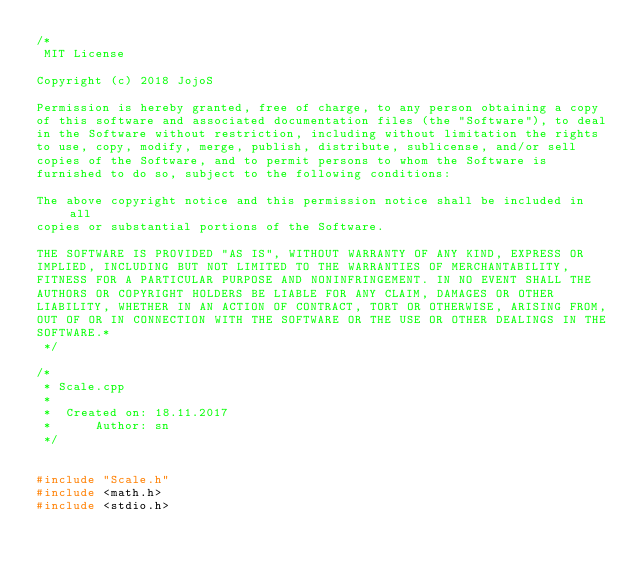Convert code to text. <code><loc_0><loc_0><loc_500><loc_500><_C++_>/*
 MIT License

Copyright (c) 2018 JojoS

Permission is hereby granted, free of charge, to any person obtaining a copy
of this software and associated documentation files (the "Software"), to deal
in the Software without restriction, including without limitation the rights
to use, copy, modify, merge, publish, distribute, sublicense, and/or sell
copies of the Software, and to permit persons to whom the Software is
furnished to do so, subject to the following conditions:

The above copyright notice and this permission notice shall be included in all
copies or substantial portions of the Software.

THE SOFTWARE IS PROVIDED "AS IS", WITHOUT WARRANTY OF ANY KIND, EXPRESS OR
IMPLIED, INCLUDING BUT NOT LIMITED TO THE WARRANTIES OF MERCHANTABILITY,
FITNESS FOR A PARTICULAR PURPOSE AND NONINFRINGEMENT. IN NO EVENT SHALL THE
AUTHORS OR COPYRIGHT HOLDERS BE LIABLE FOR ANY CLAIM, DAMAGES OR OTHER
LIABILITY, WHETHER IN AN ACTION OF CONTRACT, TORT OR OTHERWISE, ARISING FROM,
OUT OF OR IN CONNECTION WITH THE SOFTWARE OR THE USE OR OTHER DEALINGS IN THE
SOFTWARE.*
 */

/*
 * Scale.cpp
 *
 *  Created on: 18.11.2017
 *      Author: sn
 */


#include "Scale.h"
#include <math.h>
#include <stdio.h></code> 